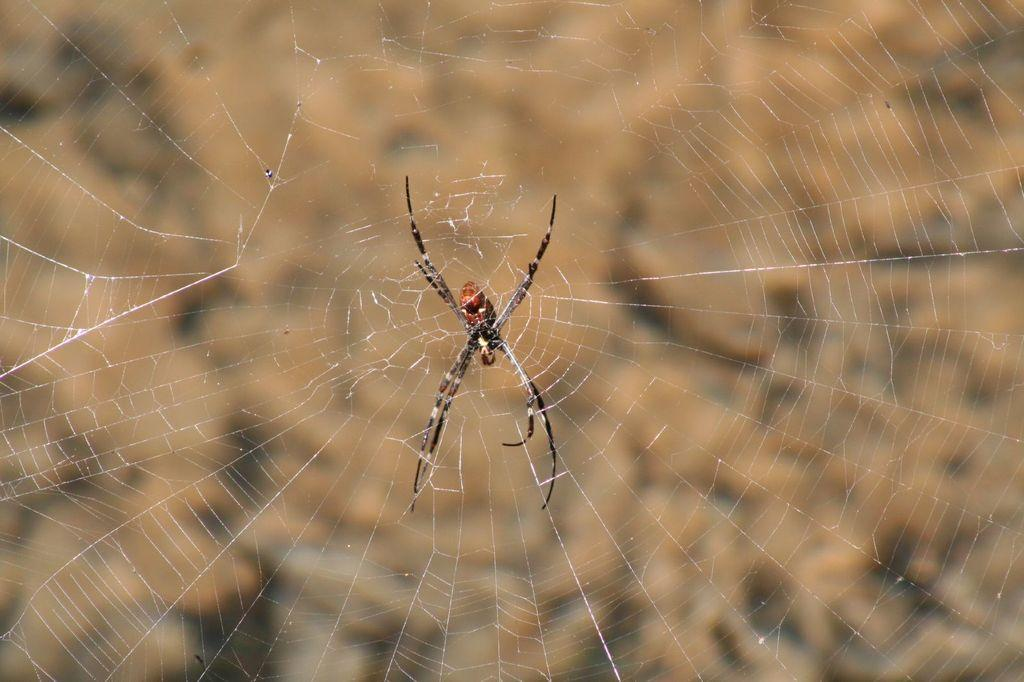What is the main subject of the image? There is a spider in the image. What is the spider associated with in the image? There is a web in the image. Can you describe the background of the image? The background of the image is blurry. How does the spider maintain its balance on the vein in the image? There is no vein present in the image, and the spider is not shown balancing on anything. 